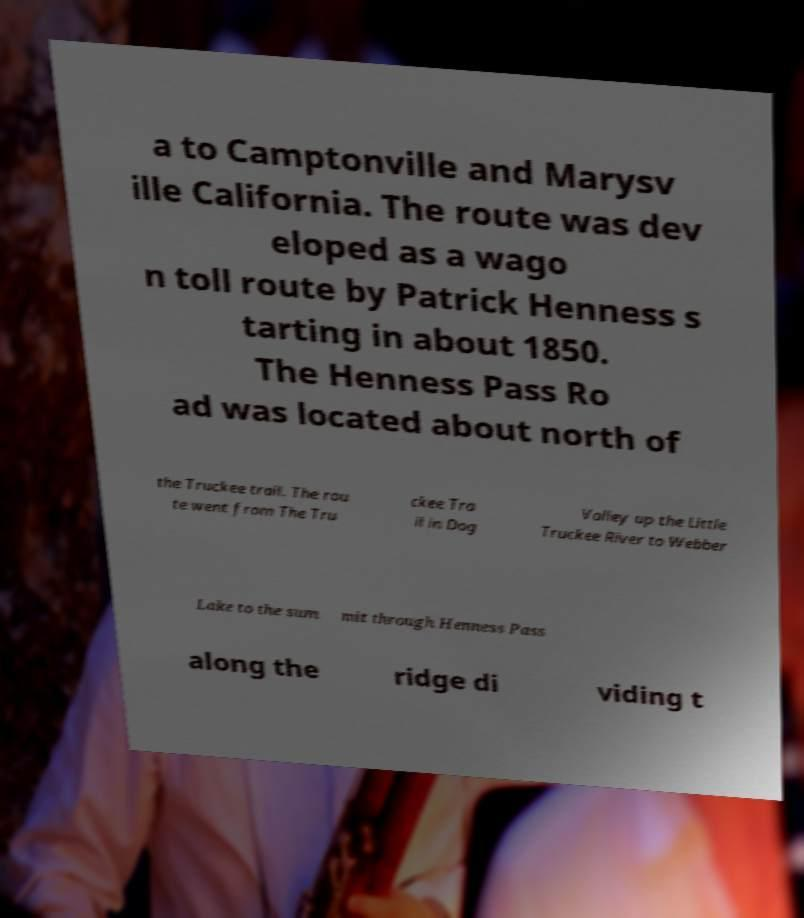Please read and relay the text visible in this image. What does it say? a to Camptonville and Marysv ille California. The route was dev eloped as a wago n toll route by Patrick Henness s tarting in about 1850. The Henness Pass Ro ad was located about north of the Truckee trail. The rou te went from The Tru ckee Tra il in Dog Valley up the Little Truckee River to Webber Lake to the sum mit through Henness Pass along the ridge di viding t 